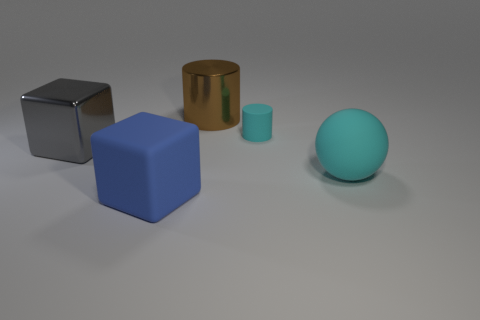What size is the cyan cylinder that is the same material as the large cyan object?
Your response must be concise. Small. Does the cylinder that is in front of the shiny cylinder have the same size as the block to the left of the blue thing?
Your answer should be very brief. No. There is a blue cube that is the same size as the brown metal cylinder; what is it made of?
Make the answer very short. Rubber. The thing that is in front of the large gray cube and to the left of the big cyan matte thing is made of what material?
Offer a terse response. Rubber. Are there any large blue shiny things?
Your answer should be compact. No. Is the color of the large matte sphere the same as the cylinder that is on the right side of the large brown shiny cylinder?
Offer a very short reply. Yes. There is a large object that is the same color as the tiny matte thing; what material is it?
Provide a succinct answer. Rubber. Is there any other thing that has the same shape as the big brown shiny object?
Your answer should be very brief. Yes. What is the shape of the cyan object that is left of the cyan thing in front of the matte thing that is behind the rubber ball?
Ensure brevity in your answer.  Cylinder. The brown thing is what shape?
Offer a terse response. Cylinder. 